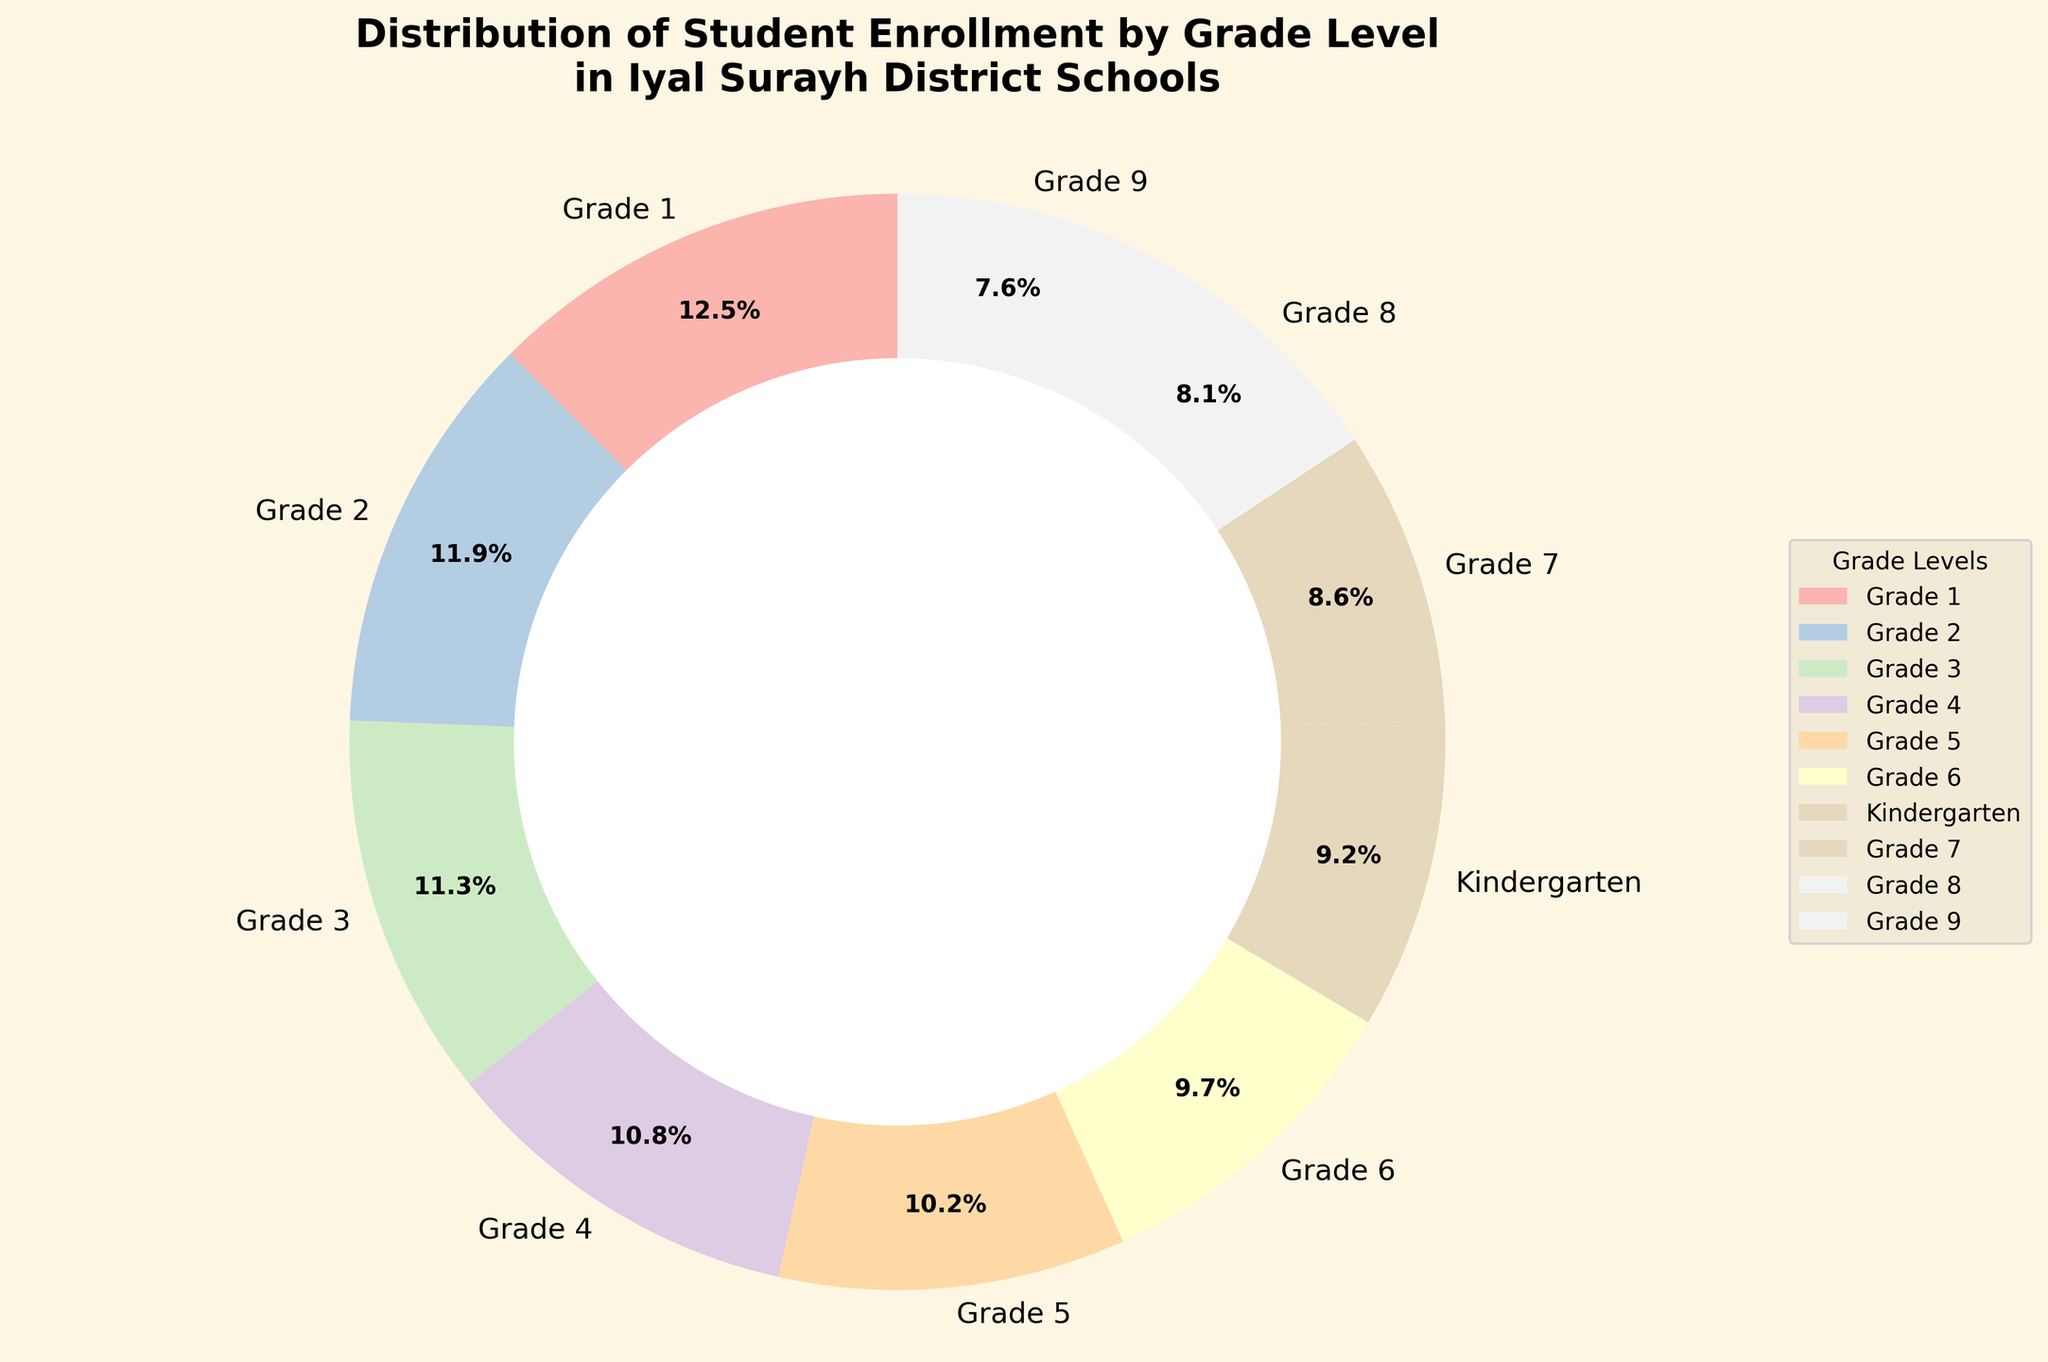What grade level has the highest student enrollment? The figure shows different sections of the pie chart representing each grade level with their respective proportions. By examining the sections, the largest segment is labeled as "Grade 1".
Answer: Grade 1 Which grade levels have a student enrollment greater than 400? To determine this, look for sections of the pie chart that represent more than a certain threshold. By examining the size and labels, the grades with more than 400 students are "Grade 1", "Grade 2", "Grade 3", "Grade 4", "Grade 5", and "Grade 6".
Answer: Grades 1, 2, 3, 4, 5, 6 What is the combined percentage of student enrollment for Kindergarten and Grade 7? Add the percentages shown on the pie chart for Kindergarten and Grade 7. Given that Kindergarten is labeled with "385" students and Grade 7 with "362" students, compute their percentages and sum them up from the visual chart details.
Answer: Around 17.0% By how much does the enrollment in Grade 9 differ from Grade 4? Determine the absolute difference between the number of students in Grade 9 and Grade 4. The figures show 318 students for Grade 9 and 452 for Grade 4. Subtract 318 from 452 to get the difference.
Answer: 134 Which grade level has the smallest student enrollment? Examine the pie chart sections to identify the smallest segment by area. The pie chart labels the smallest segment as "Grade 9".
Answer: Grade 9 What is the total percentage of student enrollment in grades 1 through 3? Add the percentages for Grade 1, Grade 2, and Grade 3 as shown on the pie chart. Grade 1 has 523 students, Grade 2 has 498 students, and Grade 3 has 475 students. From the pie chart, sum these labeled percentages.
Answer: Around 34.3% Compare the visual difference between Kindergarten and Grade 8 in terms of student enrollment. By looking at the pie chart, Kindergarten has 385 students, while Grade 8 has 340 students. Notice that the slice for Kindergarten will be visually larger than that of Grade 8.
Answer: Kindergarten has a larger slice What grade levels have an enrollment less than Kindergarten? Check the sections of the pie chart and identify the grade levels with fewer students compared to Kindergarten which has 385 students. The smaller segments represent "Grade 7", "Grade 8", and "Grade 9".
Answer: Grades 7, 8, 9 